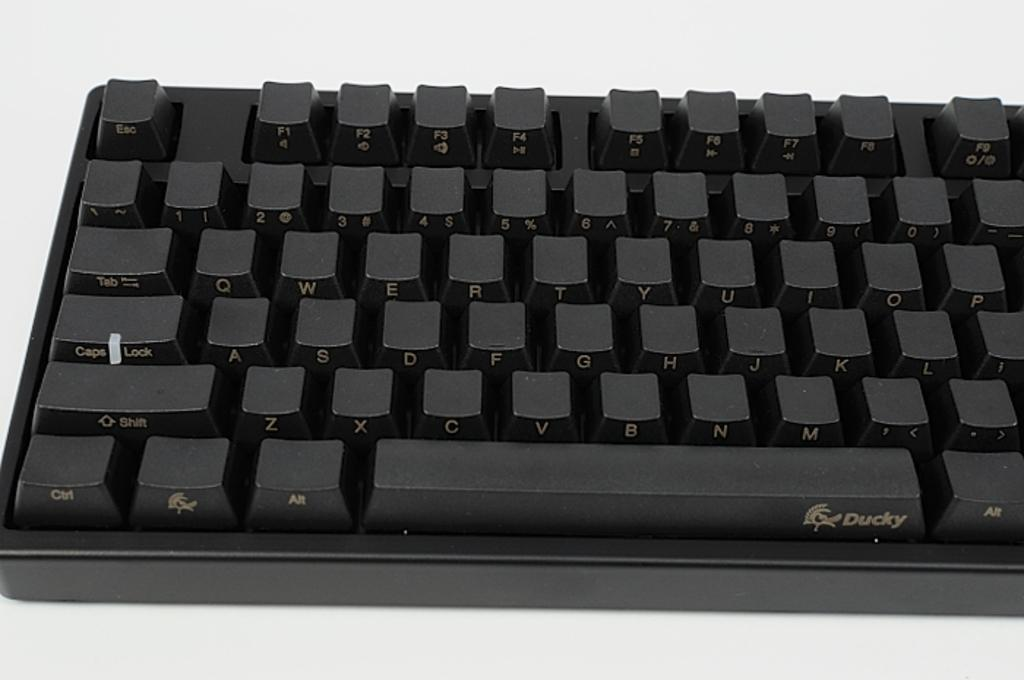<image>
Summarize the visual content of the image. A Ducky keyboard is all black and you can clearly see the caps lock button. 